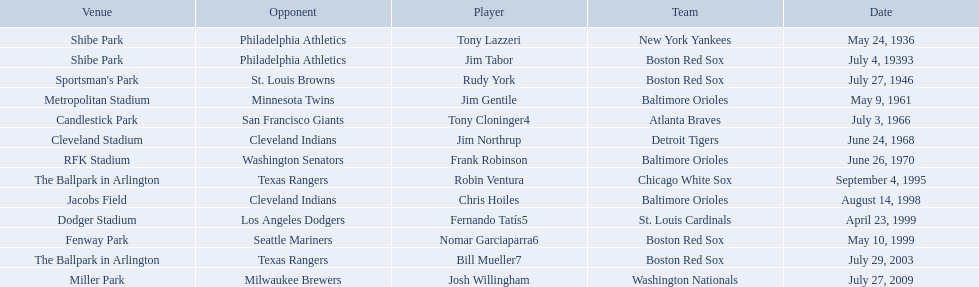Write the full table. {'header': ['Venue', 'Opponent', 'Player', 'Team', 'Date'], 'rows': [['Shibe Park', 'Philadelphia Athletics', 'Tony Lazzeri', 'New York Yankees', 'May 24, 1936'], ['Shibe Park', 'Philadelphia Athletics', 'Jim Tabor', 'Boston Red Sox', 'July 4, 19393'], ["Sportsman's Park", 'St. Louis Browns', 'Rudy York', 'Boston Red Sox', 'July 27, 1946'], ['Metropolitan Stadium', 'Minnesota Twins', 'Jim Gentile', 'Baltimore Orioles', 'May 9, 1961'], ['Candlestick Park', 'San Francisco Giants', 'Tony Cloninger4', 'Atlanta Braves', 'July 3, 1966'], ['Cleveland Stadium', 'Cleveland Indians', 'Jim Northrup', 'Detroit Tigers', 'June 24, 1968'], ['RFK Stadium', 'Washington Senators', 'Frank Robinson', 'Baltimore Orioles', 'June 26, 1970'], ['The Ballpark in Arlington', 'Texas Rangers', 'Robin Ventura', 'Chicago White Sox', 'September 4, 1995'], ['Jacobs Field', 'Cleveland Indians', 'Chris Hoiles', 'Baltimore Orioles', 'August 14, 1998'], ['Dodger Stadium', 'Los Angeles Dodgers', 'Fernando Tatís5', 'St. Louis Cardinals', 'April 23, 1999'], ['Fenway Park', 'Seattle Mariners', 'Nomar Garciaparra6', 'Boston Red Sox', 'May 10, 1999'], ['The Ballpark in Arlington', 'Texas Rangers', 'Bill Mueller7', 'Boston Red Sox', 'July 29, 2003'], ['Miller Park', 'Milwaukee Brewers', 'Josh Willingham', 'Washington Nationals', 'July 27, 2009']]} Which teams played between the years 1960 and 1970? Baltimore Orioles, Atlanta Braves, Detroit Tigers, Baltimore Orioles. Of these teams that played, which ones played against the cleveland indians? Detroit Tigers. On what day did these two teams play? June 24, 1968. 